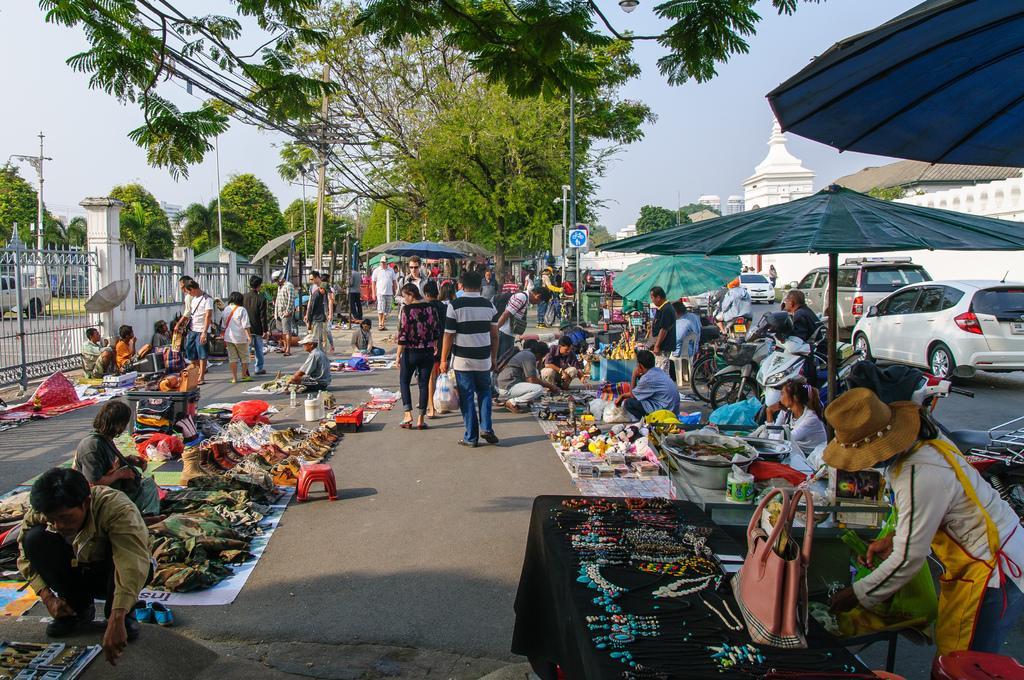Could you give a brief overview of what you see in this image? In this picture there are few clothes and footwear placed on the road and there are two persons sitting beside it and there is a woman standing and there is a table in front of her which has few jewels on it and there are few persons,vehicles,trees and buildings in the background and there is a gate and a fence wall in the left corner. 